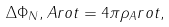Convert formula to latex. <formula><loc_0><loc_0><loc_500><loc_500>\Delta \Phi _ { N } , A r o t = 4 \pi \rho _ { A } r o t ,</formula> 